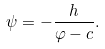Convert formula to latex. <formula><loc_0><loc_0><loc_500><loc_500>\psi = - \frac { h } { \varphi - c } .</formula> 